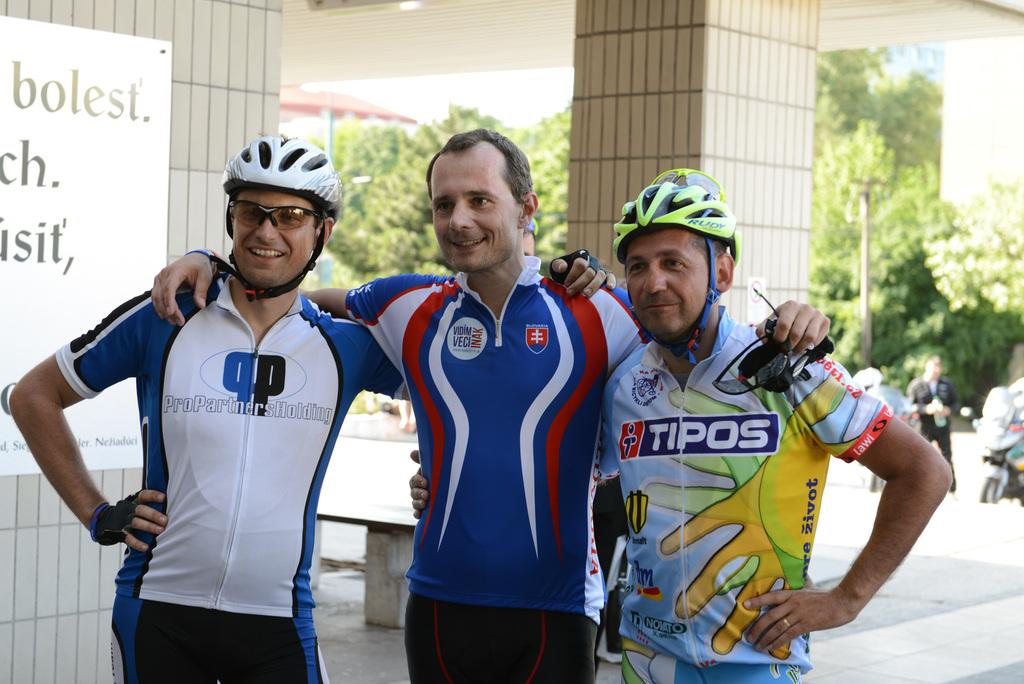<image>
Relay a brief, clear account of the picture shown. The old guy is wearing a tipos jersey 